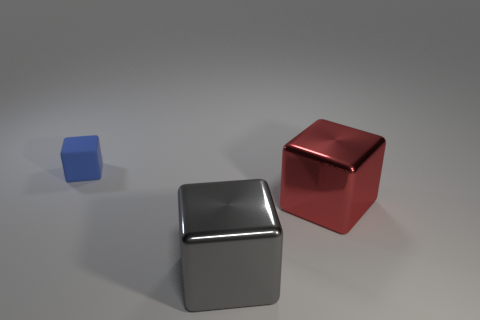What is the color of the other shiny thing that is the same shape as the big gray metal object? The other object that shares the same cubic shape as the larger gray metal cube is colored red, and it exhibits a similar high-gloss finish, reflecting the environment with a shiny surface. 